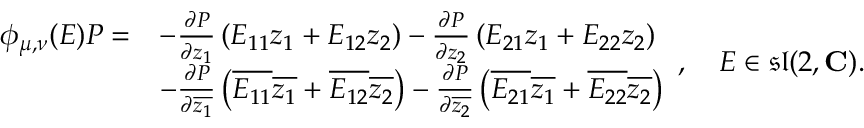<formula> <loc_0><loc_0><loc_500><loc_500>{ \begin{array} { r l } { \phi _ { \mu , \nu } ( E ) P = } & { - { \frac { \partial P } { \partial z _ { 1 } } } \left ( E _ { 1 1 } z _ { 1 } + E _ { 1 2 } z _ { 2 } \right ) - { \frac { \partial P } { \partial z _ { 2 } } } \left ( E _ { 2 1 } z _ { 1 } + E _ { 2 2 } z _ { 2 } \right ) } \\ & { - { \frac { \partial P } { \partial { \overline { { z _ { 1 } } } } } } \left ( { \overline { { E _ { 1 1 } } } } { \overline { { z _ { 1 } } } } + { \overline { { E _ { 1 2 } } } } { \overline { { z _ { 2 } } } } \right ) - { \frac { \partial P } { \partial { \overline { { z _ { 2 } } } } } } \left ( { \overline { { E _ { 2 1 } } } } { \overline { { z _ { 1 } } } } + { \overline { { E _ { 2 2 } } } } { \overline { { z _ { 2 } } } } \right ) } \end{array} } , \quad E \in { \mathfrak { s l } } ( 2 , C ) .</formula> 